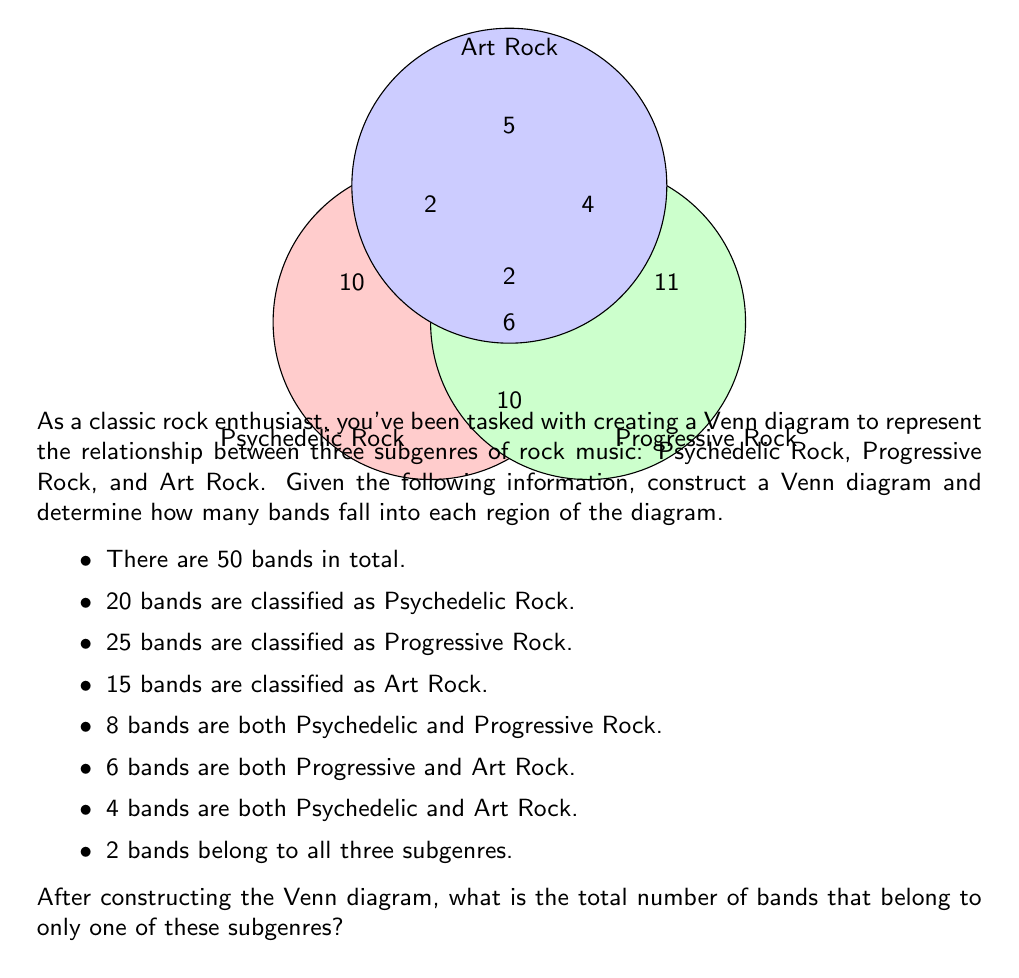Can you answer this question? Let's approach this step-by-step:

1) First, we need to identify the number of bands in each region of the Venn diagram. Let's start with the center, where all three subgenres intersect:
   - 2 bands belong to all three subgenres

2) Next, let's calculate the bands that belong to exactly two subgenres:
   - Psychedelic and Progressive: $8 - 2 = 6$
   - Progressive and Art: $6 - 2 = 4$
   - Psychedelic and Art: $4 - 2 = 2$

3) Now, we can calculate the bands that belong to only one subgenre:
   - Only Psychedelic: $20 - (6 + 2 + 2) = 10$
   - Only Progressive: $25 - (6 + 4 + 2) = 13$
   - Only Art: $15 - (4 + 2 + 2) = 7$

4) To verify our calculations, let's sum all regions:
   $2 + 6 + 4 + 2 + 10 + 13 + 7 = 44$

5) The total number of bands is 50, so there are $50 - 44 = 6$ bands that don't belong to any of these subgenres.

6) The question asks for the total number of bands that belong to only one subgenre. We add the numbers from step 3:

   $10 + 13 + 7 = 30$

Therefore, 30 bands belong to only one of these subgenres.
Answer: 30 bands 